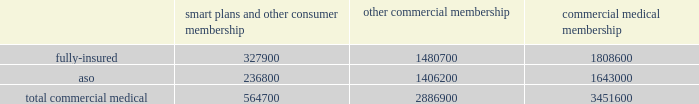We participate in a medicare health support pilot program through green ribbon health , or grh , a joint- venture company with pfizer health solutions inc .
Grh is designed to support medicare beneficiaries living with diabetes and/or congestive heart failure in central florida .
Grh uses disease management initiatives including evidence-based clinical guidelines , personal self-directed change strategies , and personal nurses to help participants navigate the health system .
Revenues under the contract with cms , which expires october 31 , 2008 unless terminated earlier , are subject to refund unless a savings target is met .
To date , all revenues have been deferred until reliable estimates are determinable .
Our products marketed to commercial segment employers and members smart plans and other consumer products over the last several years , we have developed and offered various commercial products designed to provide options and choices to employers that are annually facing substantial premium increases driven by double-digit medical cost inflation .
These smart plans , discussed more fully below , and other consumer offerings , which can be offered on either a fully-insured or aso basis , provided coverage to approximately 564700 members at december 31 , 2007 , representing approximately 16.4% ( 16.4 % ) of our total commercial medical membership as detailed below .
Smart plans and other consumer membership other commercial membership commercial medical membership .
These products are often offered to employer groups as 201cbundles 201d , where the subscribers are offered various hmo and ppo options , with various employer contribution strategies as determined by the employer .
Paramount to our product strategy , we have developed a group of innovative consumer products , styled as 201csmart 201d products , that we believe will be a long-term solution for employers .
We believe this new generation of products provides more ( 1 ) choices for the individual consumer , ( 2 ) transparency of provider costs , and ( 3 ) benefit designs that engage consumers in the costs and effectiveness of health care choices .
Innovative tools and technology are available to assist consumers with these decisions , including the trade-offs between higher premiums and point-of-service costs at the time consumers choose their plans , and to suggest ways in which the consumers can maximize their individual benefits at the point they use their plans .
We believe that when consumers can make informed choices about the cost and effectiveness of their health care , a sustainable long term solution for employers can be realized .
Smart products , which accounted for approximately 55% ( 55 % ) of enrollment in all of our consumer-choice plans as of december 31 , 2007 , are only sold to employers who use humana as their sole health insurance carrier .
Some employers have selected other types of consumer-choice products , such as , ( 1 ) a product with a high deductible , ( 2 ) a catastrophic coverage plan , or ( 3 ) ones that offer a spending account option in conjunction with more traditional medical coverage or as a stand alone plan .
Unlike our smart products , these products , while valuable in helping employers deal with near-term cost increases by shifting costs to employees , are not considered by us to be long-term comprehensive solutions to the employers 2019 cost dilemma , although we view them as an important interim step .
Our commercial hmo products provide prepaid health insurance coverage to our members through a network of independent primary care physicians , specialty physicians , and other health care providers who .
As of december 2007 what was the approximate total of the total commercial medical membership? 
Rationale: as of december 2007 the approximate total of the total commercial medical membership was 3443292.68
Computations: (564700 / 16.4)
Answer: 34432.92683. 